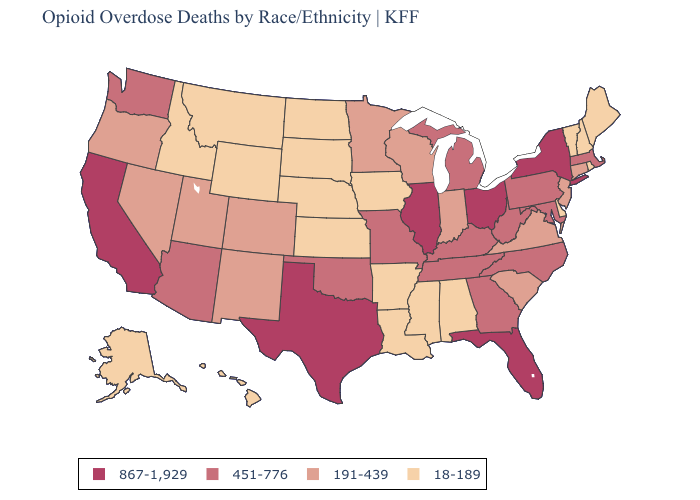Is the legend a continuous bar?
Short answer required. No. What is the value of Idaho?
Keep it brief. 18-189. What is the lowest value in the South?
Write a very short answer. 18-189. What is the value of Idaho?
Give a very brief answer. 18-189. What is the lowest value in states that border Minnesota?
Short answer required. 18-189. Does Tennessee have the lowest value in the South?
Be succinct. No. What is the lowest value in the MidWest?
Keep it brief. 18-189. Which states have the highest value in the USA?
Write a very short answer. California, Florida, Illinois, New York, Ohio, Texas. What is the value of Illinois?
Be succinct. 867-1,929. What is the highest value in the USA?
Give a very brief answer. 867-1,929. Name the states that have a value in the range 191-439?
Answer briefly. Colorado, Connecticut, Indiana, Minnesota, Nevada, New Jersey, New Mexico, Oregon, South Carolina, Utah, Virginia, Wisconsin. Among the states that border Iowa , does Illinois have the lowest value?
Concise answer only. No. Does Maryland have the highest value in the USA?
Quick response, please. No. Which states have the lowest value in the USA?
Answer briefly. Alabama, Alaska, Arkansas, Delaware, Hawaii, Idaho, Iowa, Kansas, Louisiana, Maine, Mississippi, Montana, Nebraska, New Hampshire, North Dakota, Rhode Island, South Dakota, Vermont, Wyoming. Name the states that have a value in the range 451-776?
Quick response, please. Arizona, Georgia, Kentucky, Maryland, Massachusetts, Michigan, Missouri, North Carolina, Oklahoma, Pennsylvania, Tennessee, Washington, West Virginia. 